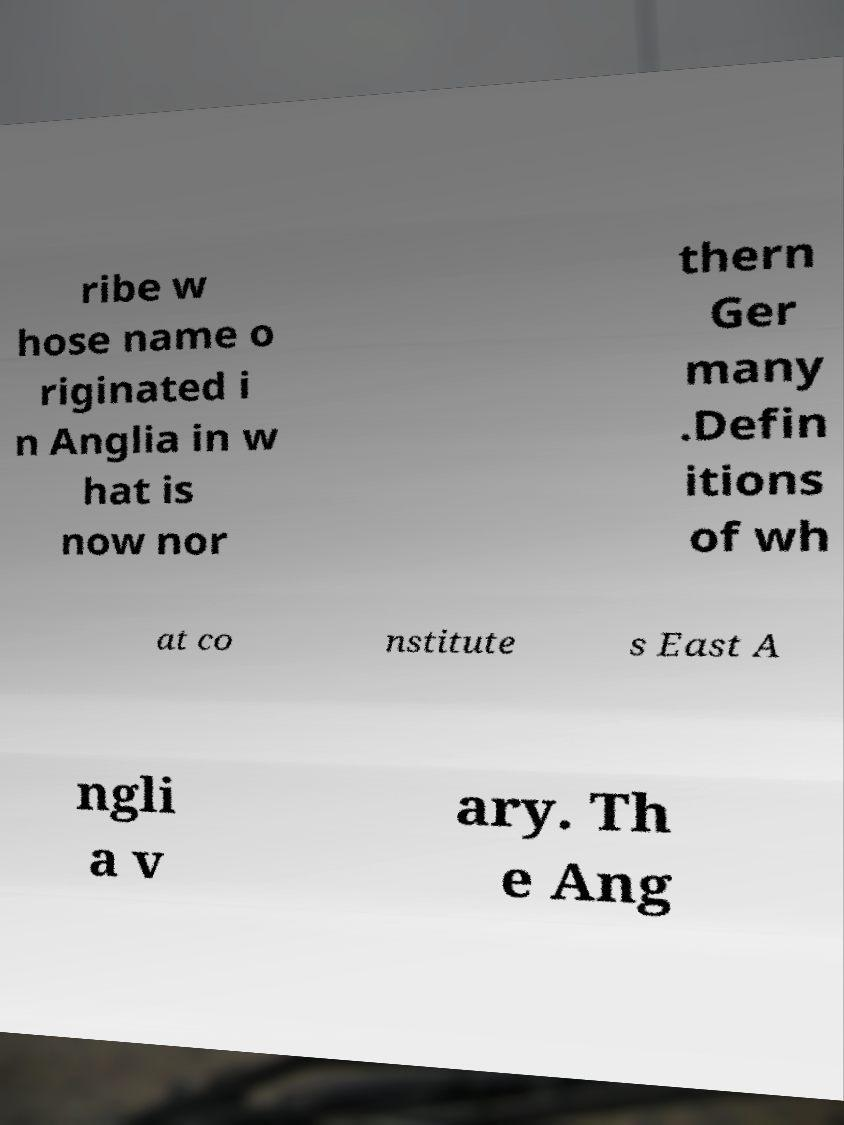Can you accurately transcribe the text from the provided image for me? ribe w hose name o riginated i n Anglia in w hat is now nor thern Ger many .Defin itions of wh at co nstitute s East A ngli a v ary. Th e Ang 